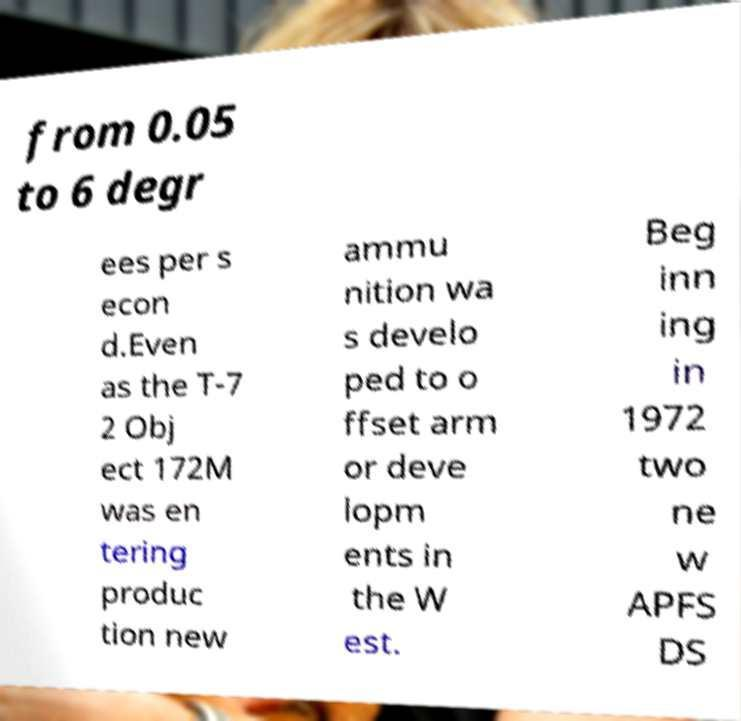Please read and relay the text visible in this image. What does it say? from 0.05 to 6 degr ees per s econ d.Even as the T-7 2 Obj ect 172M was en tering produc tion new ammu nition wa s develo ped to o ffset arm or deve lopm ents in the W est. Beg inn ing in 1972 two ne w APFS DS 